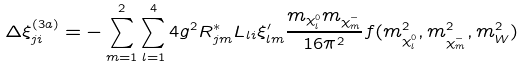Convert formula to latex. <formula><loc_0><loc_0><loc_500><loc_500>\Delta \xi ^ { ( 3 a ) } _ { j i } = - \sum _ { m = 1 } ^ { 2 } \sum _ { l = 1 } ^ { 4 } 4 g ^ { 2 } R ^ { * } _ { j m } L _ { l i } { \xi ^ { \prime } _ { l m } } \frac { m _ { \chi ^ { 0 } _ { l } } m _ { \chi _ { m } ^ { - } } } { 1 6 \pi ^ { 2 } } f ( m ^ { 2 } _ { \chi ^ { 0 } _ { l } } , m ^ { 2 } _ { \chi _ { m } ^ { - } } , m ^ { 2 } _ { W } )</formula> 